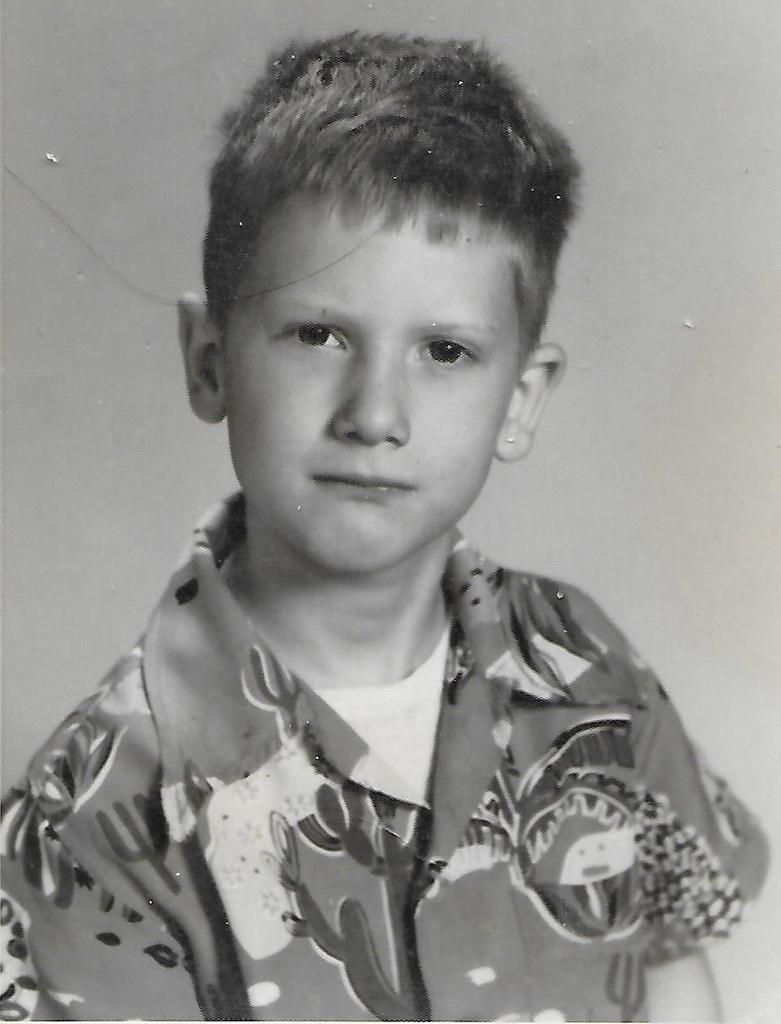Please provide a concise description of this image. This picture is in black and white. The boy in front of the picture who is wearing white T-shirt and a shirt is looking at the camera. He might be posing for the photo. 